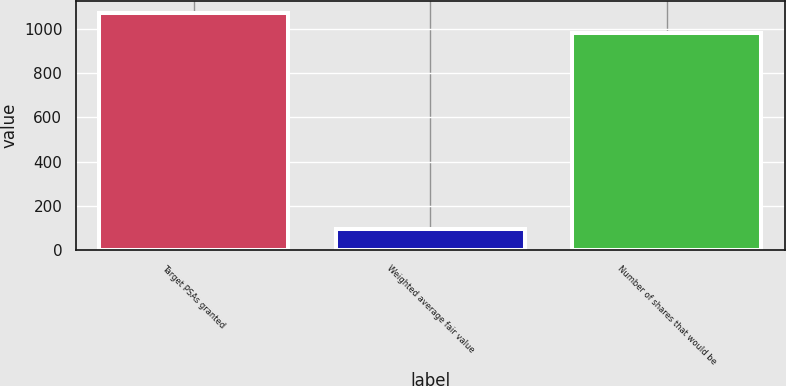Convert chart. <chart><loc_0><loc_0><loc_500><loc_500><bar_chart><fcel>Target PSAs granted<fcel>Weighted average fair value<fcel>Number of shares that would be<nl><fcel>1071.7<fcel>96<fcel>982<nl></chart> 